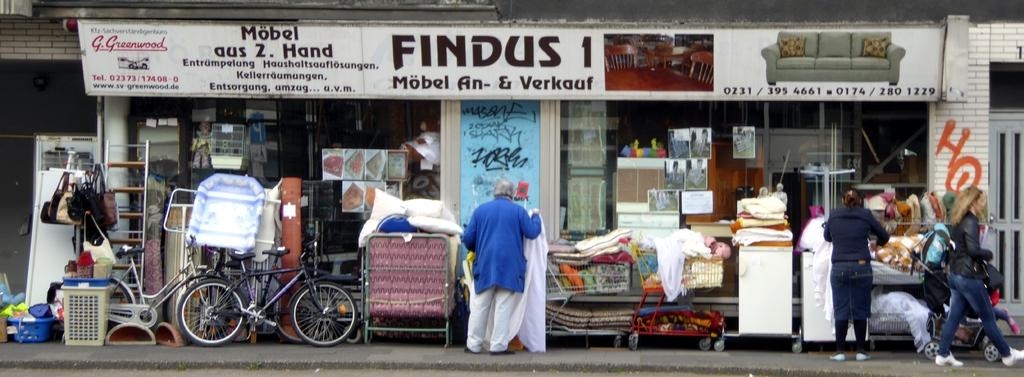<image>
Relay a brief, clear account of the picture shown. A store has a sign above it reading FINDUS 1. 